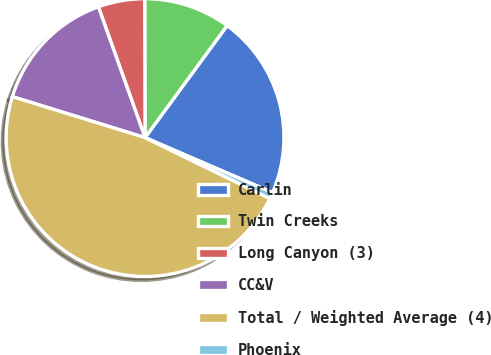<chart> <loc_0><loc_0><loc_500><loc_500><pie_chart><fcel>Carlin<fcel>Twin Creeks<fcel>Long Canyon (3)<fcel>CC&V<fcel>Total / Weighted Average (4)<fcel>Phoenix<nl><fcel>21.42%<fcel>10.1%<fcel>5.42%<fcel>14.78%<fcel>47.54%<fcel>0.74%<nl></chart> 